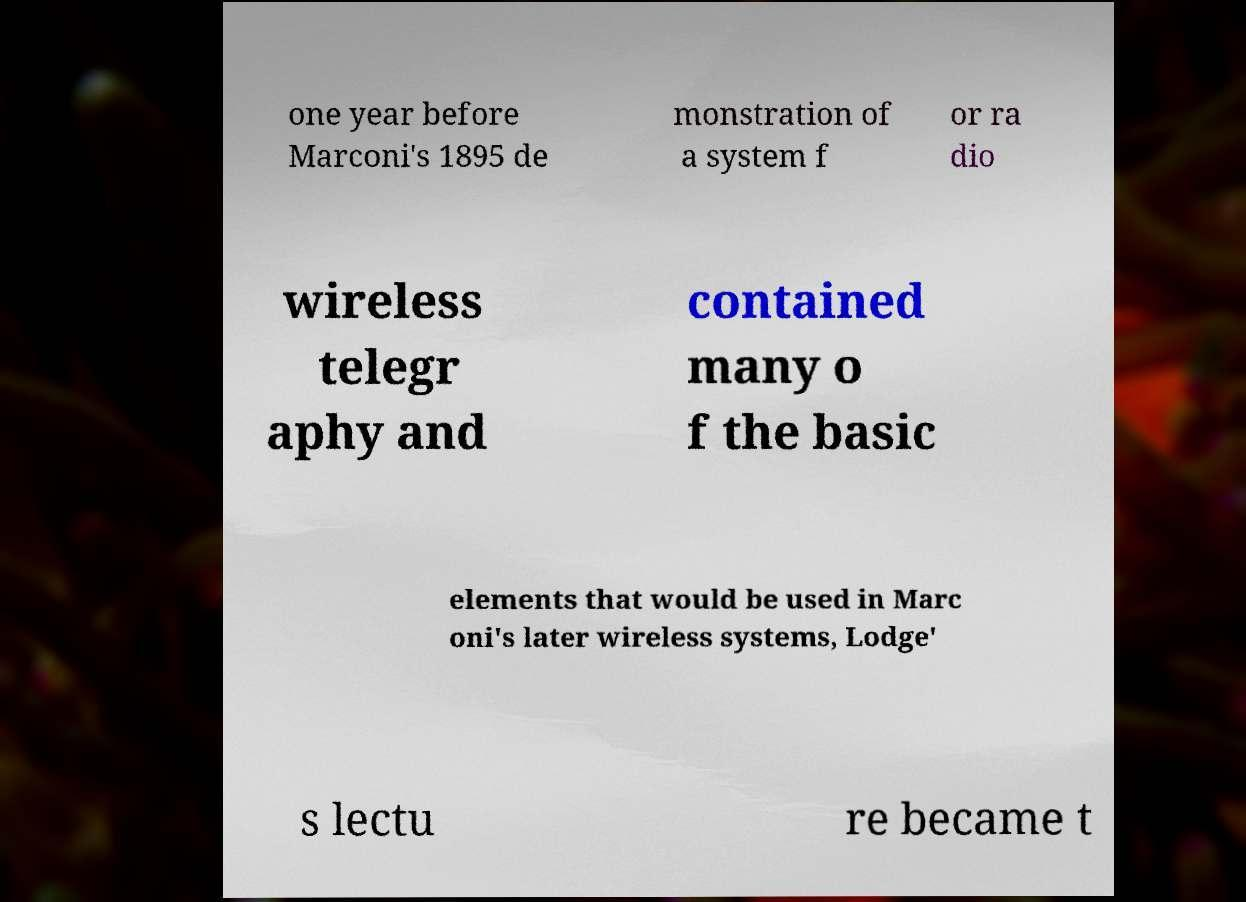What messages or text are displayed in this image? I need them in a readable, typed format. one year before Marconi's 1895 de monstration of a system f or ra dio wireless telegr aphy and contained many o f the basic elements that would be used in Marc oni's later wireless systems, Lodge' s lectu re became t 